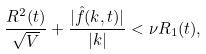<formula> <loc_0><loc_0><loc_500><loc_500>\frac { R ^ { 2 } ( t ) } { \sqrt { V } } + \frac { | \hat { f } ( k , t ) | } { | k | } < \nu R _ { 1 } ( t ) ,</formula> 